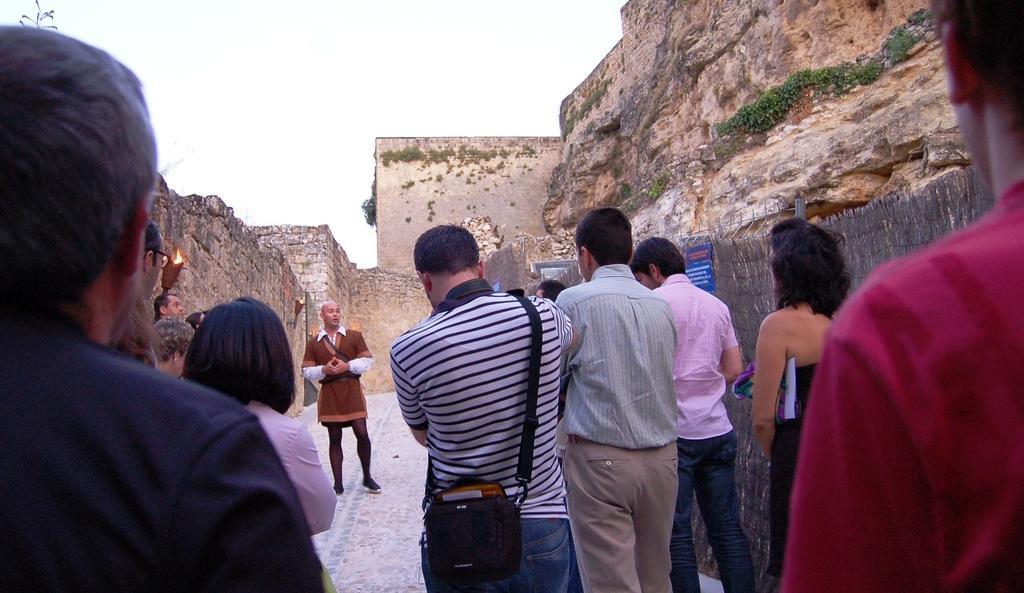Could you give a brief overview of what you see in this image? In the foreground of this image, there are few people standing where a man is wearing a bag. In the background, there is a man standing, wall, fencing, cliff and the sky. 